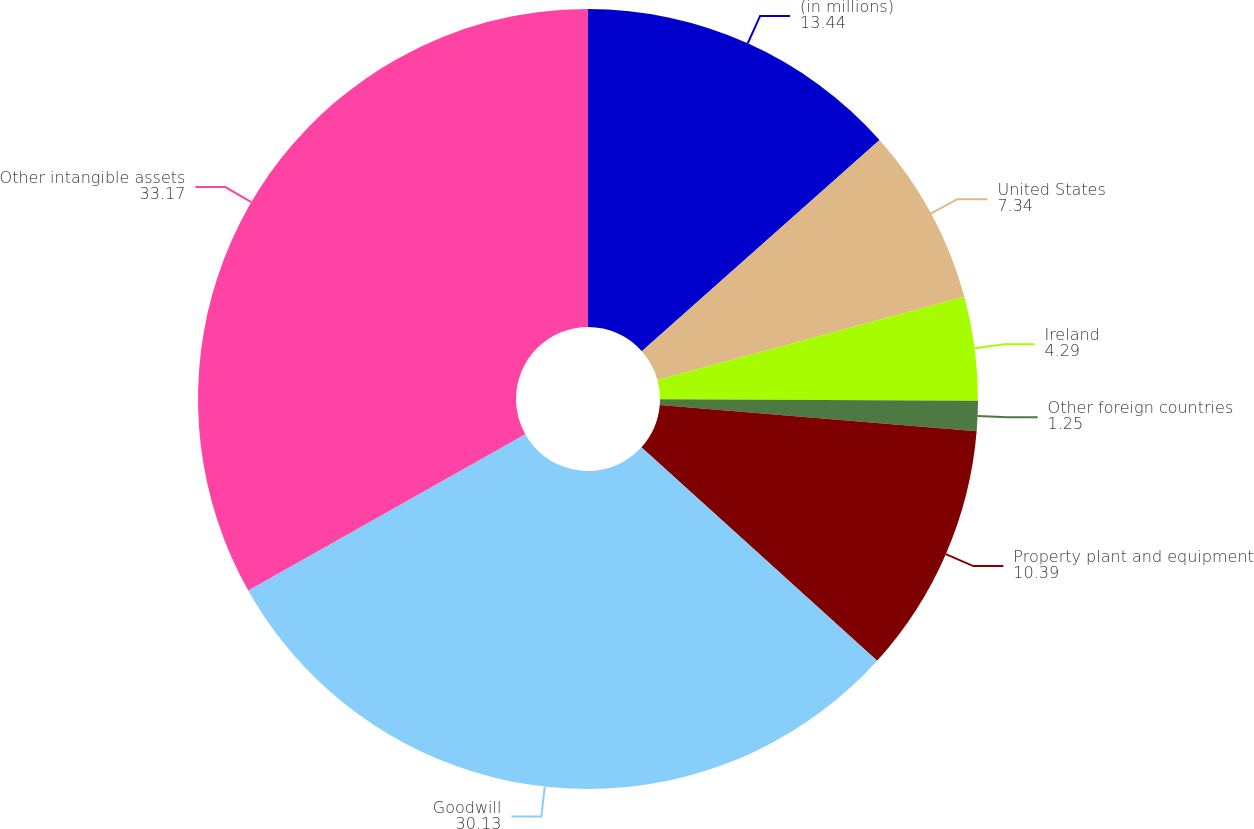Convert chart to OTSL. <chart><loc_0><loc_0><loc_500><loc_500><pie_chart><fcel>(in millions)<fcel>United States<fcel>Ireland<fcel>Other foreign countries<fcel>Property plant and equipment<fcel>Goodwill<fcel>Other intangible assets<nl><fcel>13.44%<fcel>7.34%<fcel>4.29%<fcel>1.25%<fcel>10.39%<fcel>30.13%<fcel>33.17%<nl></chart> 